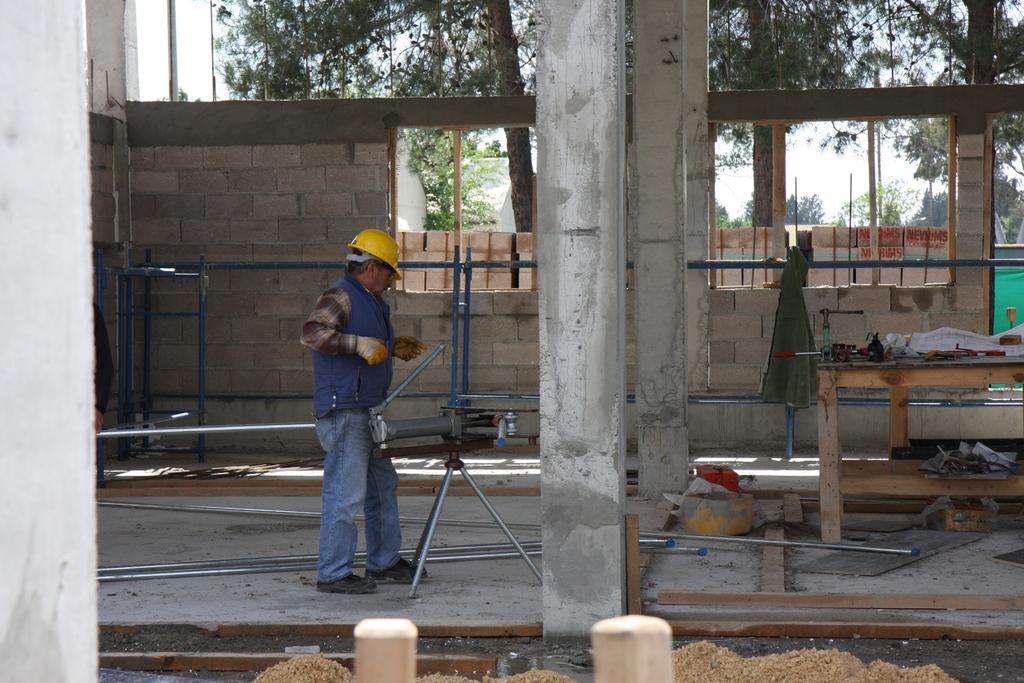Describe this image in one or two sentences. In the center of the image there are pillars. On the left side of the image we can see a person standing at a pillar. On the right side there is a table. In the background we can see trees, bricks, houses, trees and sky. At the bottom there is a sand. 